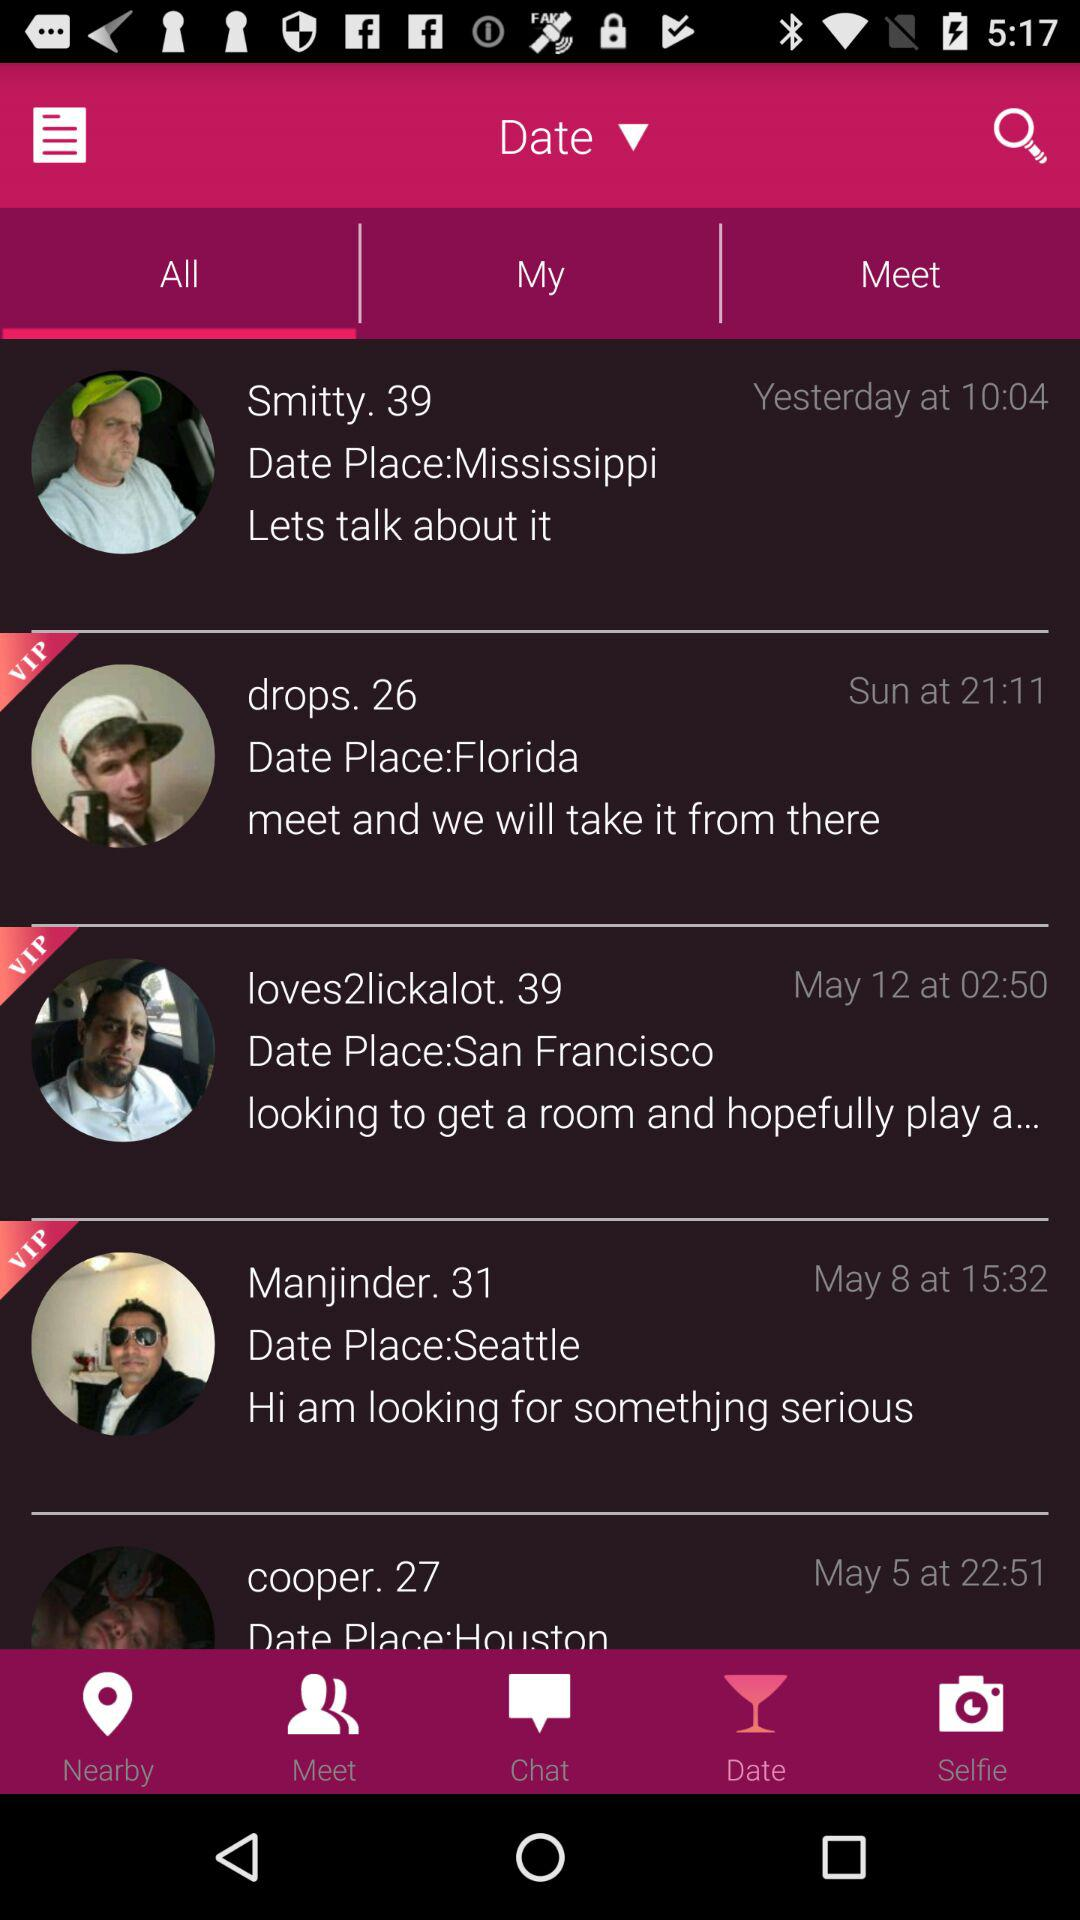On what date was the information about Manjinder posted? The information about Manjinder was posted on May 8. 